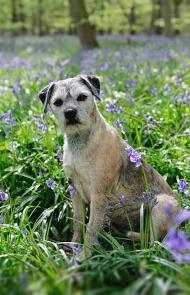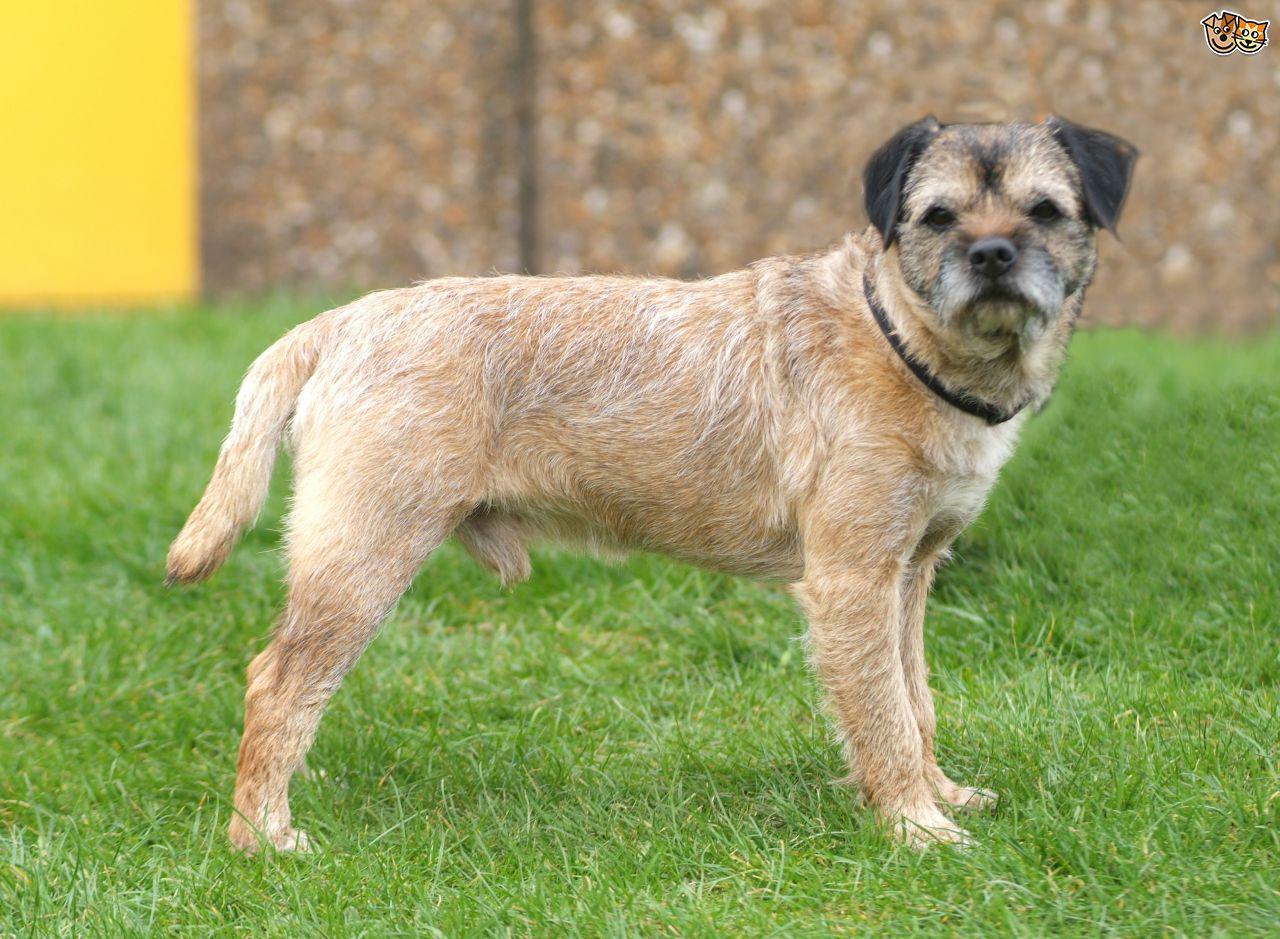The first image is the image on the left, the second image is the image on the right. Evaluate the accuracy of this statement regarding the images: "Each image contains only one dog and one is sitting in one image and standing in the other image.". Is it true? Answer yes or no. Yes. The first image is the image on the left, the second image is the image on the right. Evaluate the accuracy of this statement regarding the images: "There is a dog in the right image, sitting down.". Is it true? Answer yes or no. No. 